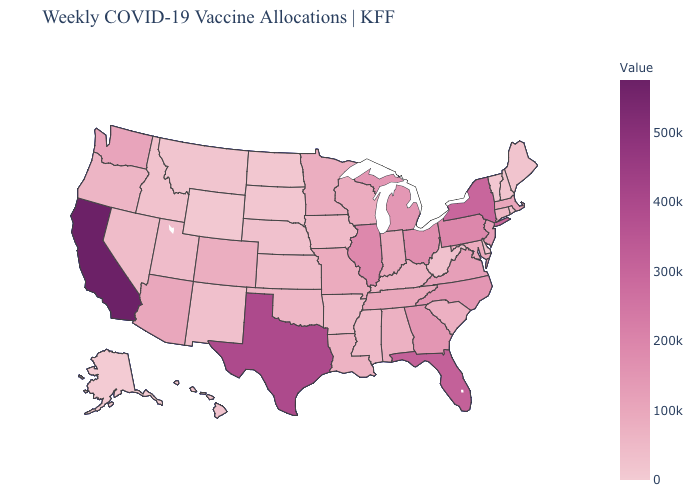Among the states that border Virginia , does Kentucky have the highest value?
Keep it brief. No. Among the states that border Florida , which have the highest value?
Be succinct. Georgia. Which states have the lowest value in the USA?
Be succinct. Alaska. Does Louisiana have the lowest value in the South?
Give a very brief answer. No. Which states have the highest value in the USA?
Short answer required. California. Among the states that border Colorado , which have the highest value?
Short answer required. Arizona. Does the map have missing data?
Concise answer only. No. Does Alaska have the lowest value in the USA?
Be succinct. Yes. Among the states that border Minnesota , which have the highest value?
Write a very short answer. Wisconsin. 